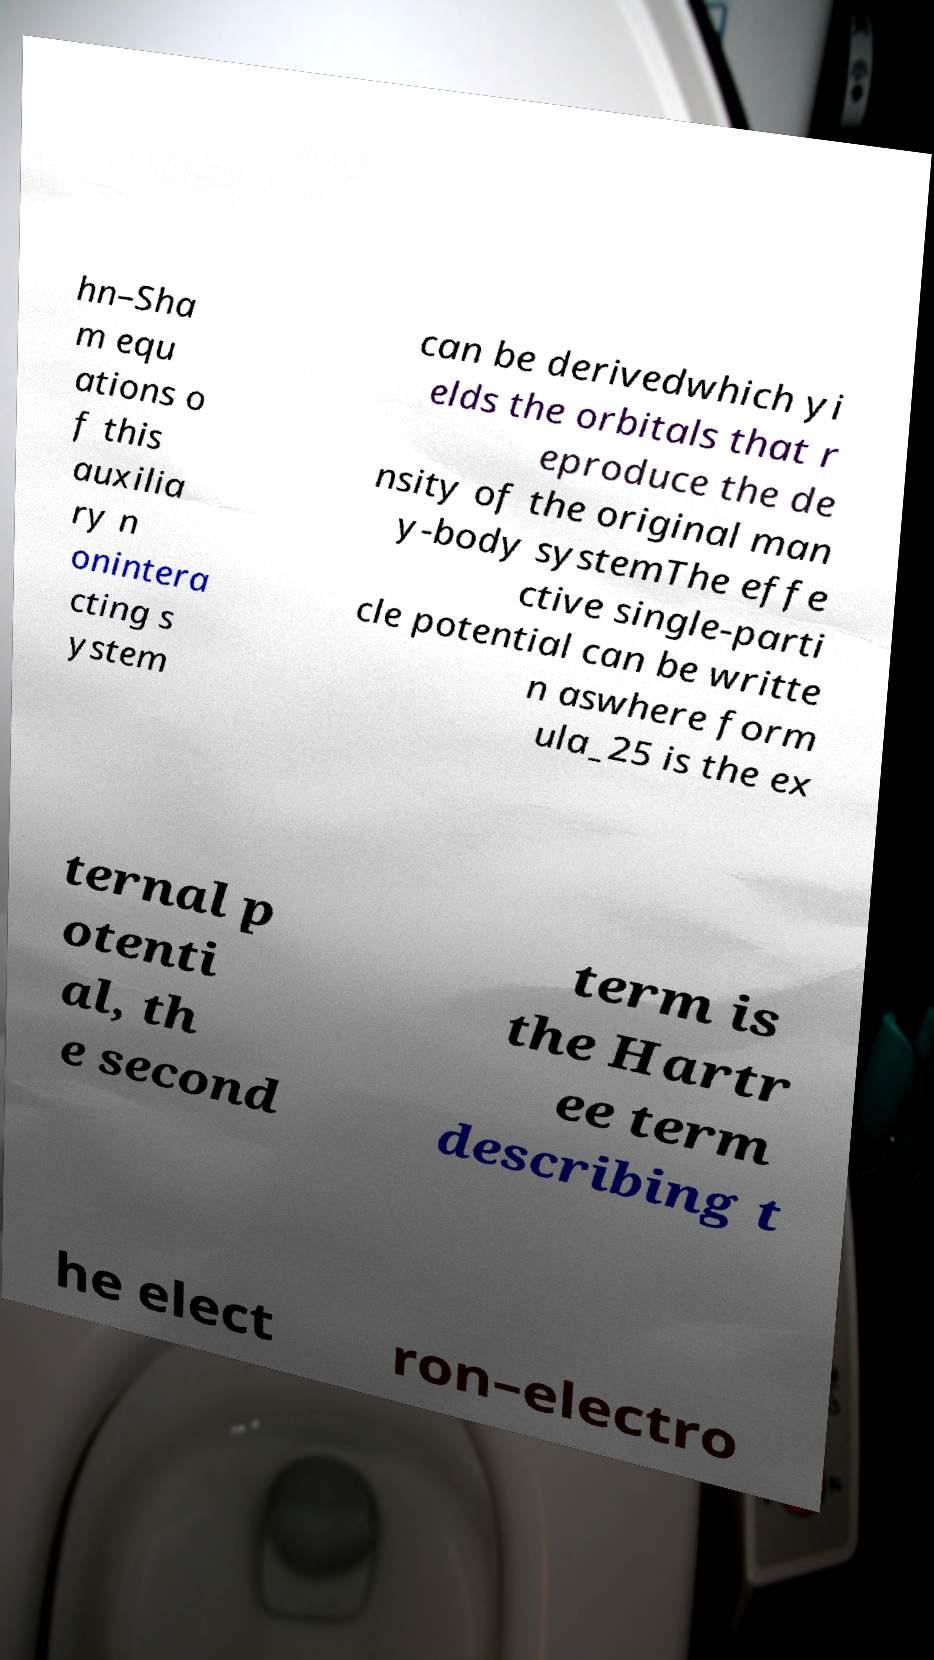There's text embedded in this image that I need extracted. Can you transcribe it verbatim? hn–Sha m equ ations o f this auxilia ry n onintera cting s ystem can be derivedwhich yi elds the orbitals that r eproduce the de nsity of the original man y-body systemThe effe ctive single-parti cle potential can be writte n aswhere form ula_25 is the ex ternal p otenti al, th e second term is the Hartr ee term describing t he elect ron–electro 